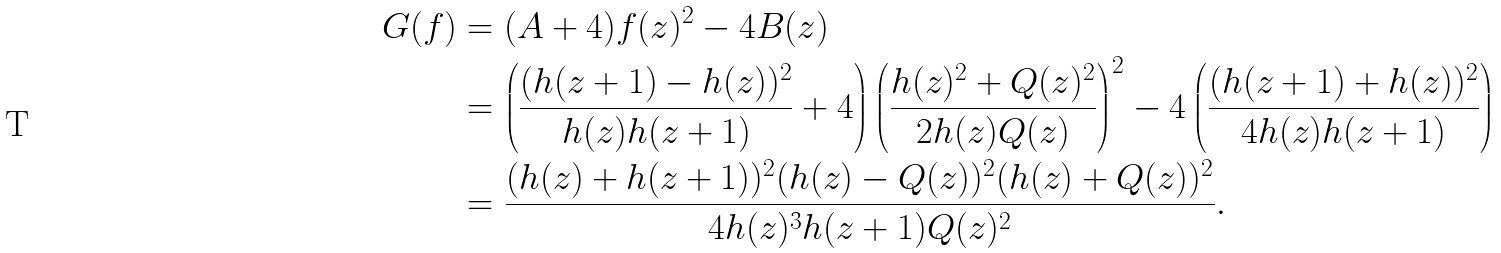<formula> <loc_0><loc_0><loc_500><loc_500>G ( f ) & = ( A + 4 ) f ( z ) ^ { 2 } - 4 B ( z ) \\ & = \left ( \frac { ( h ( z + 1 ) - h ( z ) ) ^ { 2 } } { h ( z ) h ( z + 1 ) } + 4 \right ) \left ( \frac { h ( z ) ^ { 2 } + Q ( z ) ^ { 2 } } { 2 h ( z ) Q ( z ) } \right ) ^ { 2 } - 4 \left ( \frac { ( h ( z + 1 ) + h ( z ) ) ^ { 2 } } { 4 h ( z ) h ( z + 1 ) } \right ) \\ & = \frac { ( h ( z ) + h ( z + 1 ) ) ^ { 2 } ( h ( z ) - Q ( z ) ) ^ { 2 } ( h ( z ) + Q ( z ) ) ^ { 2 } } { 4 h ( z ) ^ { 3 } h ( z + 1 ) Q ( z ) ^ { 2 } } .</formula> 